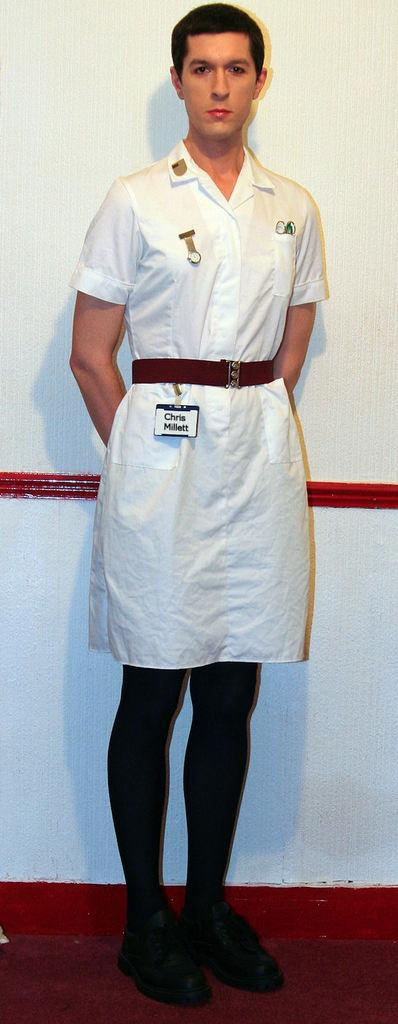<image>
Share a concise interpretation of the image provided. a person that is wearing a name tag with Chris on it 